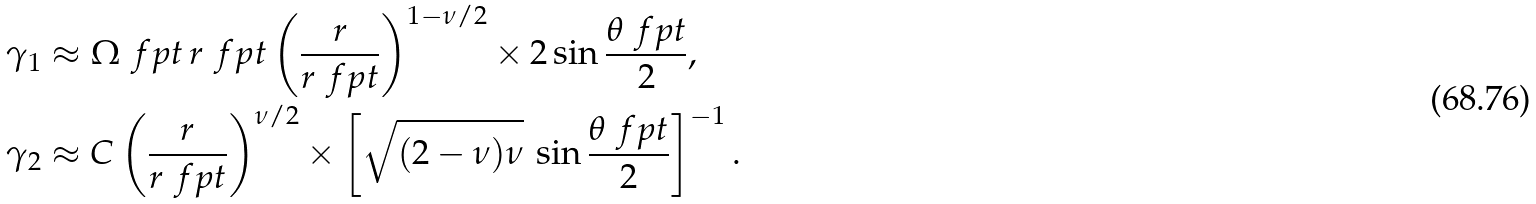<formula> <loc_0><loc_0><loc_500><loc_500>\gamma _ { 1 } & \approx \Omega _ { \ } f p t \, r _ { \ } f p t \left ( \frac { r } { r _ { \ } f p t } \right ) ^ { 1 - \nu / 2 } \times 2 \sin \frac { \theta _ { \ } f p t } { 2 } , \\ \gamma _ { 2 } & \approx C \left ( \frac { r } { r _ { \ } f p t } \right ) ^ { \nu / 2 } \times \left [ \sqrt { ( 2 - \nu ) \nu } \, \sin \frac { \theta _ { \ } f p t } { 2 } \right ] ^ { - 1 } .</formula> 